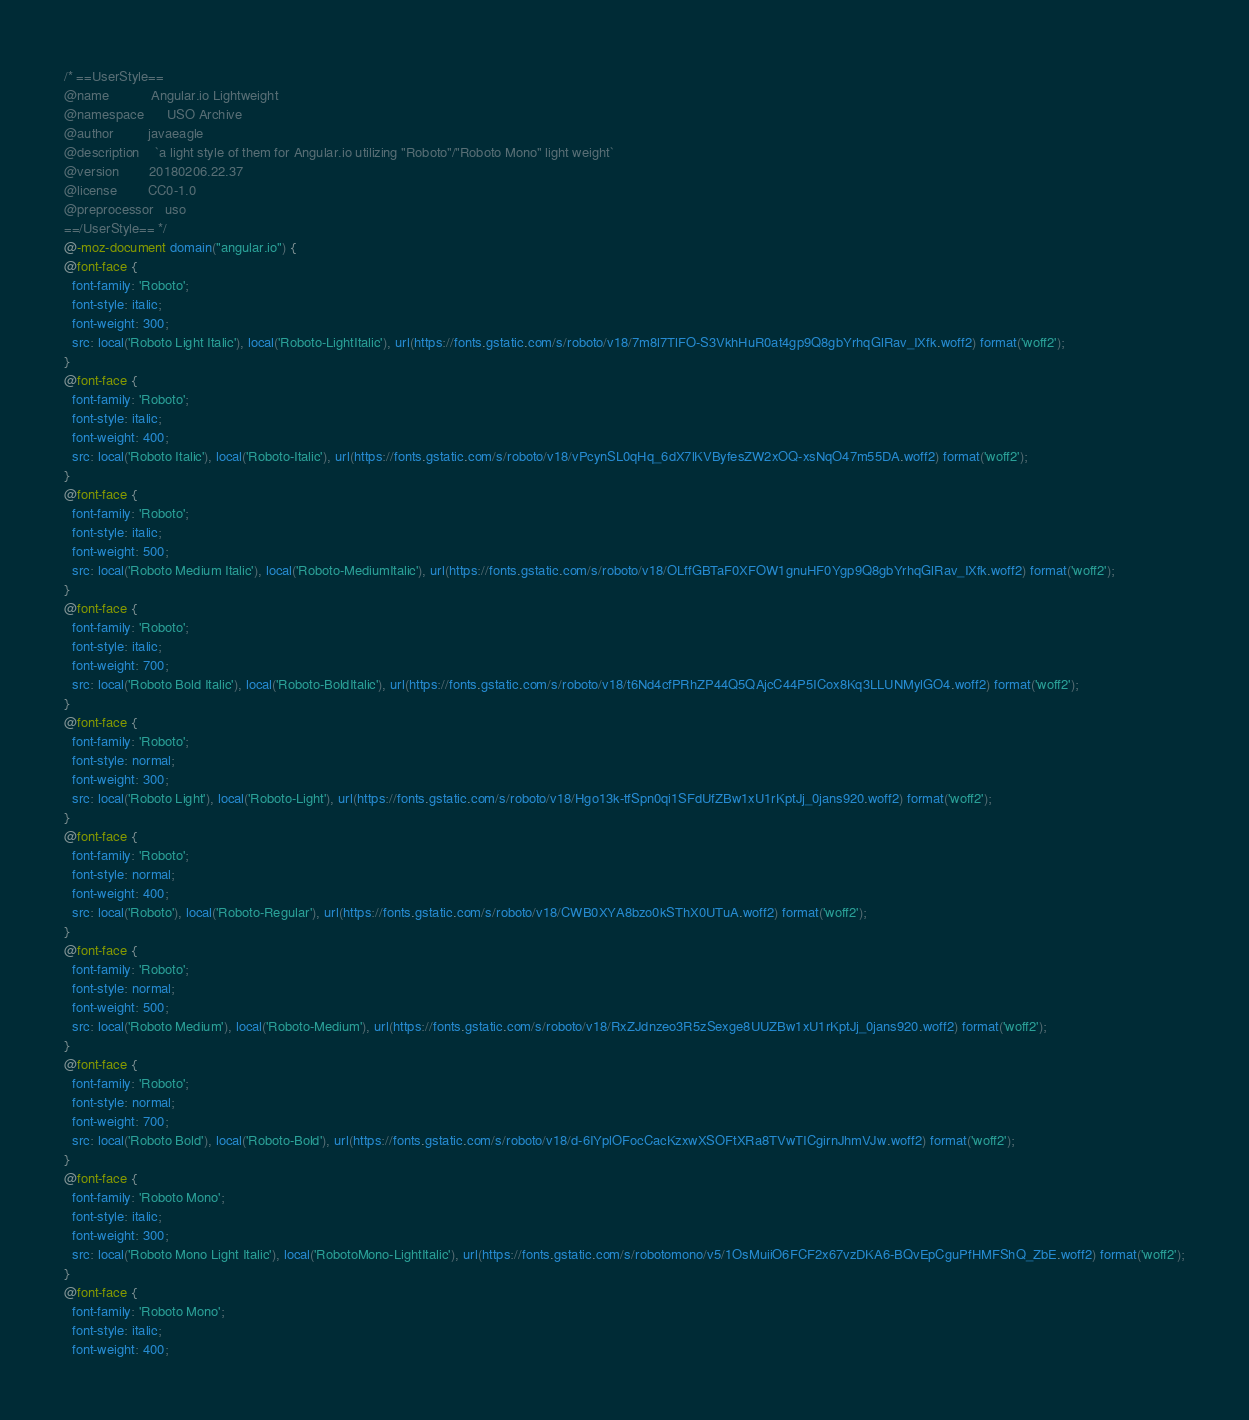<code> <loc_0><loc_0><loc_500><loc_500><_CSS_>/* ==UserStyle==
@name           Angular.io Lightweight
@namespace      USO Archive
@author         javaeagle
@description    `a light style of them for Angular.io utilizing "Roboto"/"Roboto Mono" light weight`
@version        20180206.22.37
@license        CC0-1.0
@preprocessor   uso
==/UserStyle== */
@-moz-document domain("angular.io") {
@font-face {
  font-family: 'Roboto';
  font-style: italic;
  font-weight: 300;
  src: local('Roboto Light Italic'), local('Roboto-LightItalic'), url(https://fonts.gstatic.com/s/roboto/v18/7m8l7TlFO-S3VkhHuR0at4gp9Q8gbYrhqGlRav_IXfk.woff2) format('woff2');
}
@font-face {
  font-family: 'Roboto';
  font-style: italic;
  font-weight: 400;
  src: local('Roboto Italic'), local('Roboto-Italic'), url(https://fonts.gstatic.com/s/roboto/v18/vPcynSL0qHq_6dX7lKVByfesZW2xOQ-xsNqO47m55DA.woff2) format('woff2');
}
@font-face {
  font-family: 'Roboto';
  font-style: italic;
  font-weight: 500;
  src: local('Roboto Medium Italic'), local('Roboto-MediumItalic'), url(https://fonts.gstatic.com/s/roboto/v18/OLffGBTaF0XFOW1gnuHF0Ygp9Q8gbYrhqGlRav_IXfk.woff2) format('woff2');
}
@font-face {
  font-family: 'Roboto';
  font-style: italic;
  font-weight: 700;
  src: local('Roboto Bold Italic'), local('Roboto-BoldItalic'), url(https://fonts.gstatic.com/s/roboto/v18/t6Nd4cfPRhZP44Q5QAjcC44P5ICox8Kq3LLUNMylGO4.woff2) format('woff2');
}
@font-face {
  font-family: 'Roboto';
  font-style: normal;
  font-weight: 300;
  src: local('Roboto Light'), local('Roboto-Light'), url(https://fonts.gstatic.com/s/roboto/v18/Hgo13k-tfSpn0qi1SFdUfZBw1xU1rKptJj_0jans920.woff2) format('woff2');
}
@font-face {
  font-family: 'Roboto';
  font-style: normal;
  font-weight: 400;
  src: local('Roboto'), local('Roboto-Regular'), url(https://fonts.gstatic.com/s/roboto/v18/CWB0XYA8bzo0kSThX0UTuA.woff2) format('woff2');
}
@font-face {
  font-family: 'Roboto';
  font-style: normal;
  font-weight: 500;
  src: local('Roboto Medium'), local('Roboto-Medium'), url(https://fonts.gstatic.com/s/roboto/v18/RxZJdnzeo3R5zSexge8UUZBw1xU1rKptJj_0jans920.woff2) format('woff2');
}
@font-face {
  font-family: 'Roboto';
  font-style: normal;
  font-weight: 700;
  src: local('Roboto Bold'), local('Roboto-Bold'), url(https://fonts.gstatic.com/s/roboto/v18/d-6IYplOFocCacKzxwXSOFtXRa8TVwTICgirnJhmVJw.woff2) format('woff2');
}
@font-face {
  font-family: 'Roboto Mono';
  font-style: italic;
  font-weight: 300;
  src: local('Roboto Mono Light Italic'), local('RobotoMono-LightItalic'), url(https://fonts.gstatic.com/s/robotomono/v5/1OsMuiiO6FCF2x67vzDKA6-BQvEpCguPfHMFShQ_ZbE.woff2) format('woff2');
}
@font-face {
  font-family: 'Roboto Mono';
  font-style: italic;
  font-weight: 400;</code> 